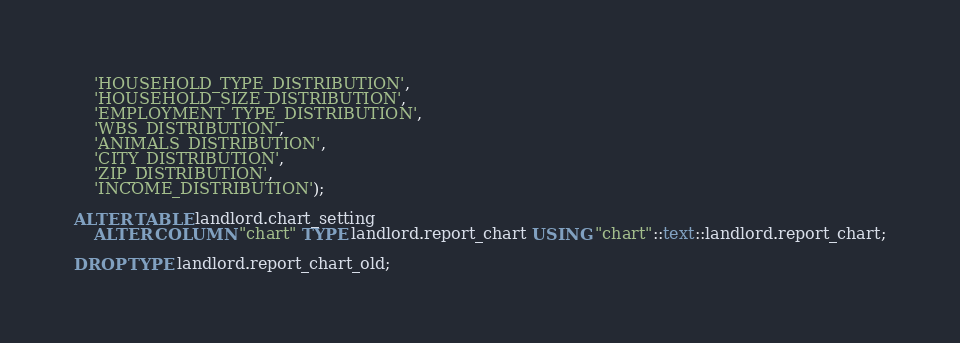<code> <loc_0><loc_0><loc_500><loc_500><_SQL_>    'HOUSEHOLD_TYPE_DISTRIBUTION',
    'HOUSEHOLD_SIZE_DISTRIBUTION',
    'EMPLOYMENT_TYPE_DISTRIBUTION',
    'WBS_DISTRIBUTION',
    'ANIMALS_DISTRIBUTION',
    'CITY_DISTRIBUTION',
    'ZIP_DISTRIBUTION',
    'INCOME_DISTRIBUTION');

ALTER TABLE landlord.chart_setting
    ALTER COLUMN "chart" TYPE landlord.report_chart USING "chart"::text::landlord.report_chart;

DROP TYPE landlord.report_chart_old;</code> 